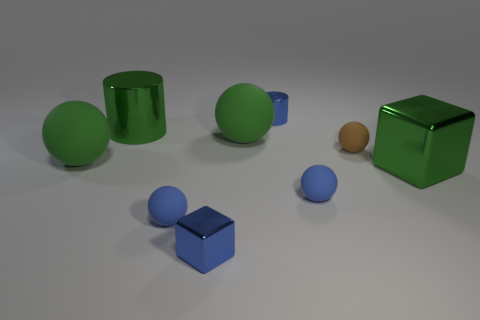Subtract all small brown rubber spheres. How many spheres are left? 4 Subtract all yellow cubes. How many blue spheres are left? 2 Add 1 tiny matte balls. How many objects exist? 10 Subtract all blue spheres. How many spheres are left? 3 Subtract all cylinders. How many objects are left? 7 Subtract all brown spheres. Subtract all brown cubes. How many spheres are left? 4 Add 6 small brown matte balls. How many small brown matte balls are left? 7 Add 8 big rubber spheres. How many big rubber spheres exist? 10 Subtract 0 gray cubes. How many objects are left? 9 Subtract all large green metal cylinders. Subtract all small red metal things. How many objects are left? 8 